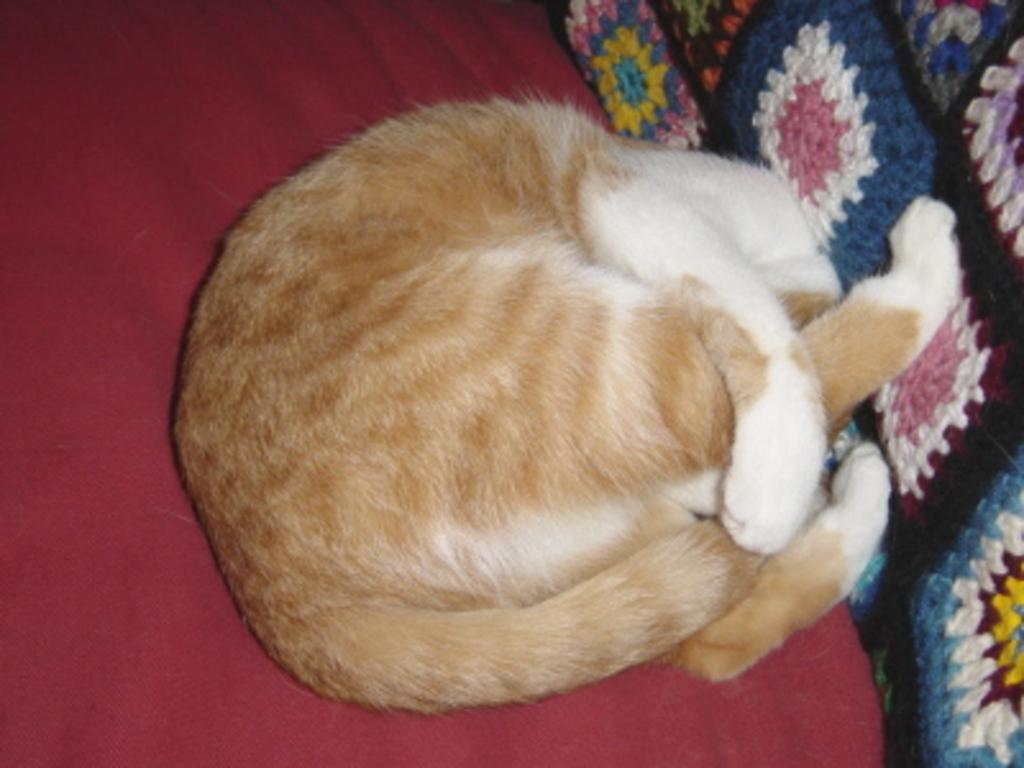What type of animal is in the image? There is a cat in the image. Where is the cat located in the image? The cat is on a surface in the image. What can be seen on the right side of the image? There is a woolen cloth on the right side in the image. What color is the cherry that the cat is resting on in the image? There is no cherry present in the image, and the cat is not resting on any cherry. How does the hydrant contribute to the image? There is no hydrant present in the image. 